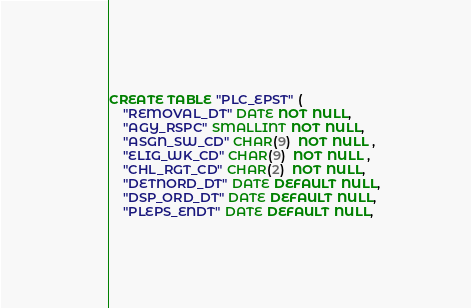<code> <loc_0><loc_0><loc_500><loc_500><_SQL_>
CREATE TABLE "PLC_EPST" (
    "REMOVAL_DT" DATE NOT NULL,
    "AGY_RSPC" SMALLINT NOT NULL,
    "ASGN_SW_CD" CHAR(9)  NOT NULL ,
    "ELIG_WK_CD" CHAR(9)  NOT NULL ,
    "CHL_RGT_CD" CHAR(2)  NOT NULL,
    "DETNORD_DT" DATE DEFAULT NULL,
    "DSP_ORD_DT" DATE DEFAULT NULL,
    "PLEPS_ENDT" DATE DEFAULT NULL,</code> 